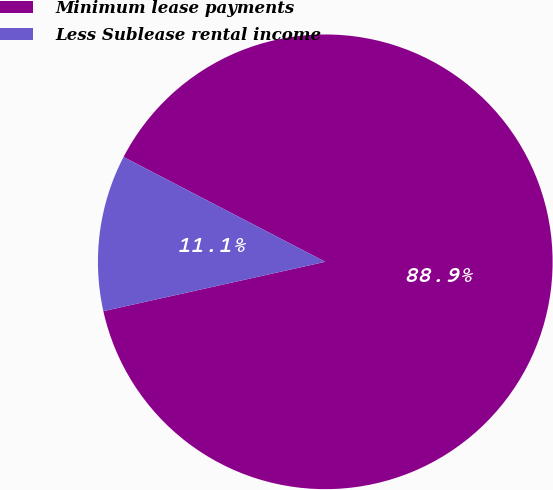<chart> <loc_0><loc_0><loc_500><loc_500><pie_chart><fcel>Minimum lease payments<fcel>Less Sublease rental income<nl><fcel>88.89%<fcel>11.11%<nl></chart> 